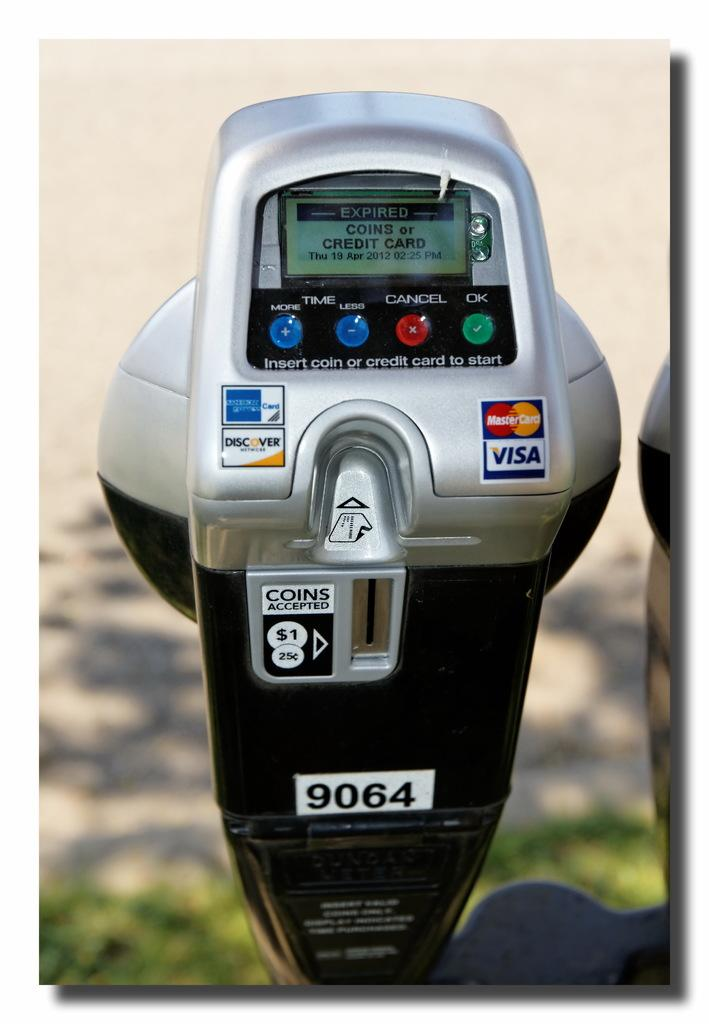<image>
Create a compact narrative representing the image presented. A device on a window advertises credit cards including Visa and MasterCard. 